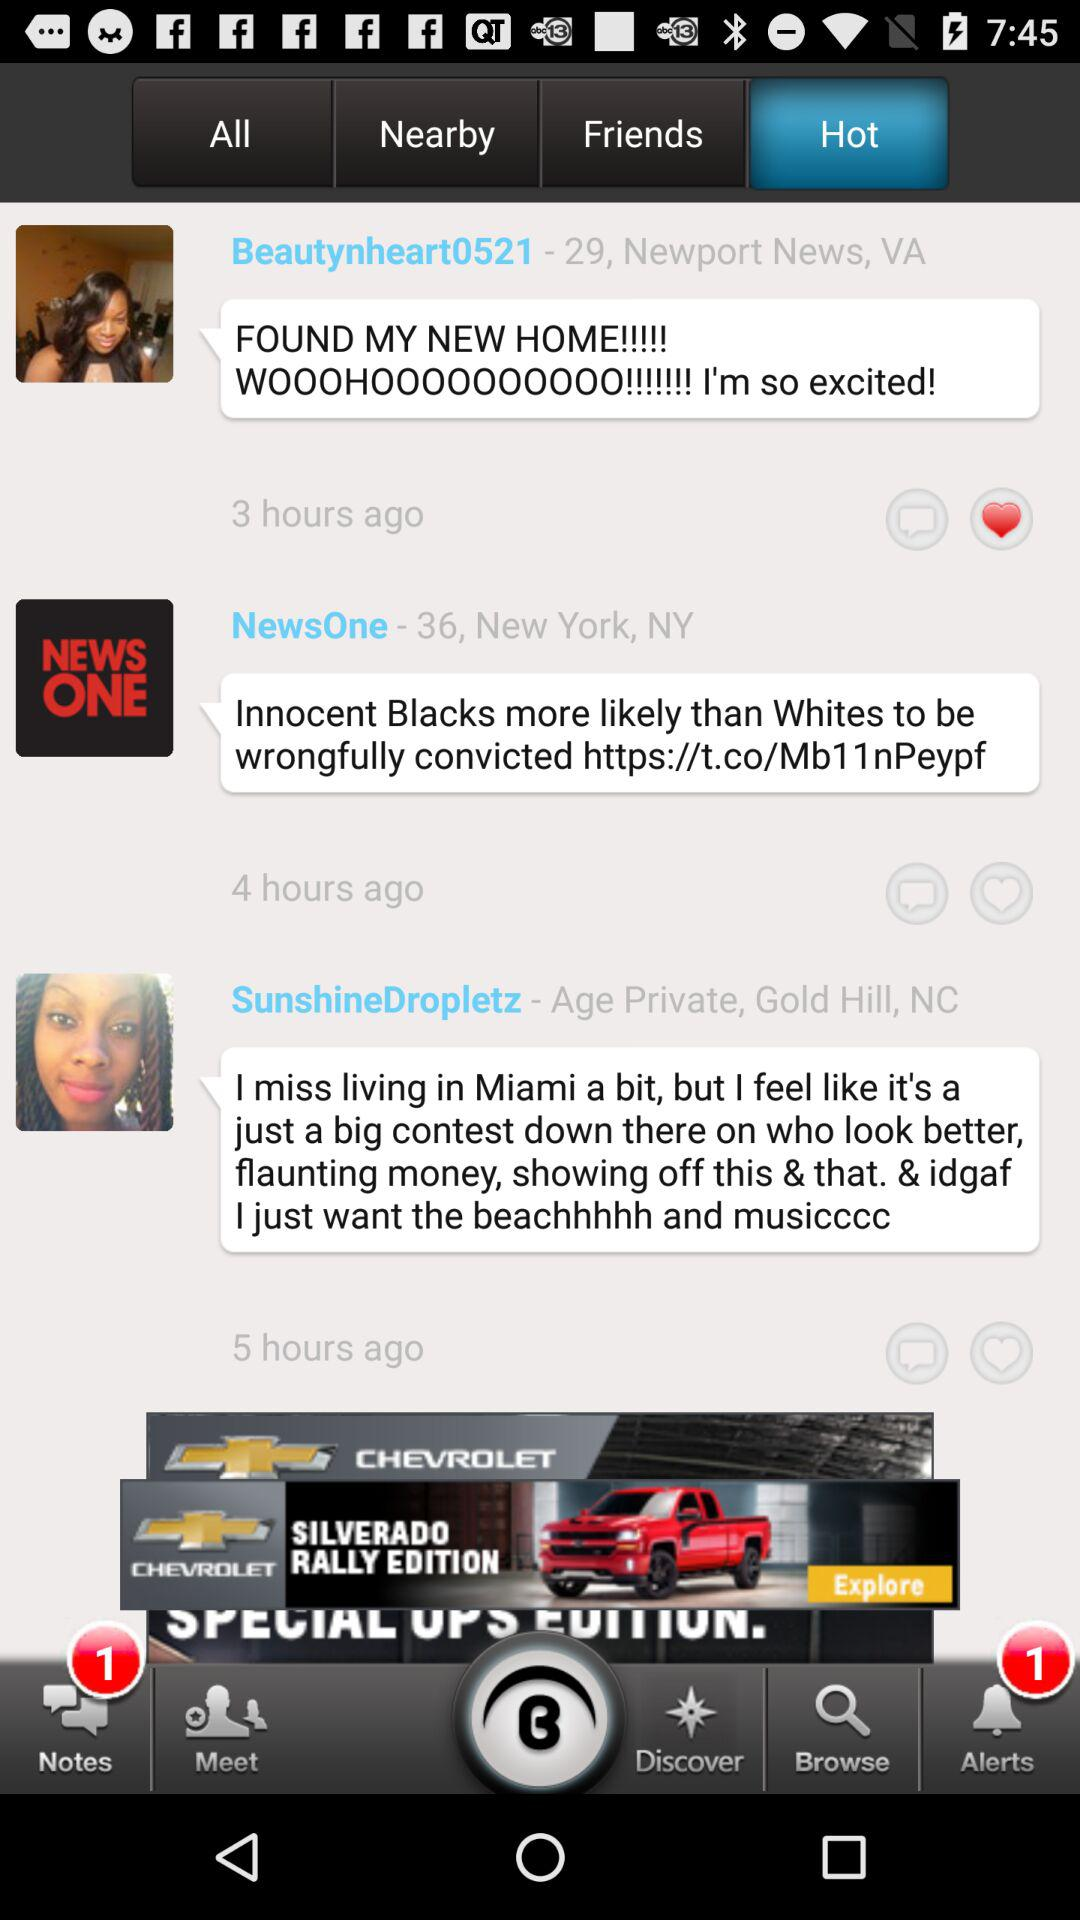What is the username? The usernames are "Beautynheart0521", "NewsOne" and "SunshineDropletz". 